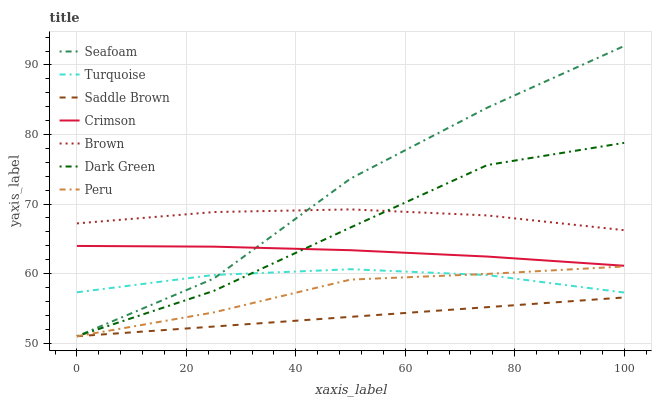Does Saddle Brown have the minimum area under the curve?
Answer yes or no. Yes. Does Seafoam have the maximum area under the curve?
Answer yes or no. Yes. Does Turquoise have the minimum area under the curve?
Answer yes or no. No. Does Turquoise have the maximum area under the curve?
Answer yes or no. No. Is Saddle Brown the smoothest?
Answer yes or no. Yes. Is Seafoam the roughest?
Answer yes or no. Yes. Is Turquoise the smoothest?
Answer yes or no. No. Is Turquoise the roughest?
Answer yes or no. No. Does Seafoam have the lowest value?
Answer yes or no. Yes. Does Turquoise have the lowest value?
Answer yes or no. No. Does Seafoam have the highest value?
Answer yes or no. Yes. Does Turquoise have the highest value?
Answer yes or no. No. Is Saddle Brown less than Turquoise?
Answer yes or no. Yes. Is Crimson greater than Turquoise?
Answer yes or no. Yes. Does Seafoam intersect Turquoise?
Answer yes or no. Yes. Is Seafoam less than Turquoise?
Answer yes or no. No. Is Seafoam greater than Turquoise?
Answer yes or no. No. Does Saddle Brown intersect Turquoise?
Answer yes or no. No. 